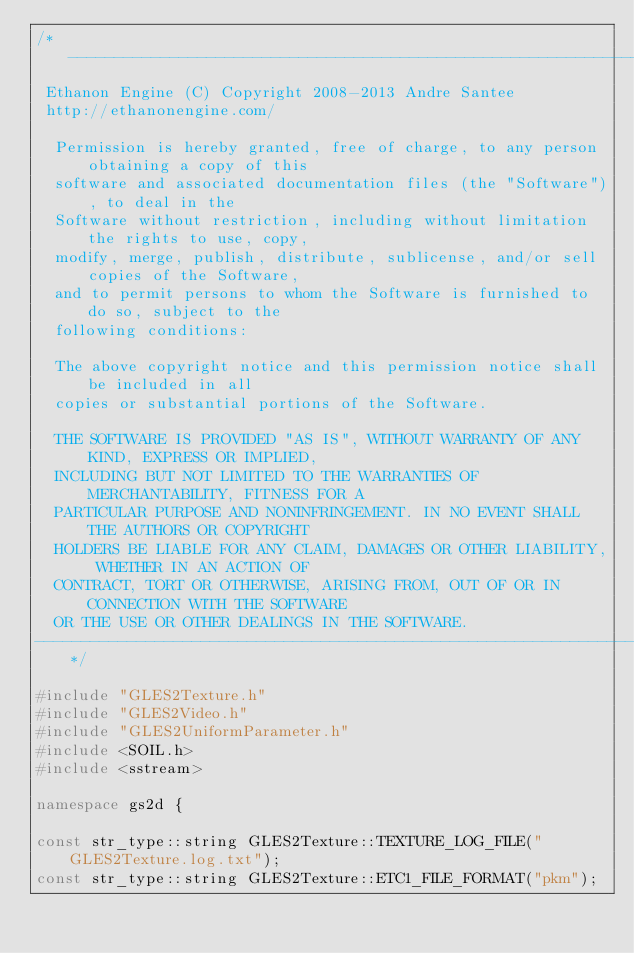<code> <loc_0><loc_0><loc_500><loc_500><_C++_>/*--------------------------------------------------------------------------------------
 Ethanon Engine (C) Copyright 2008-2013 Andre Santee
 http://ethanonengine.com/

	Permission is hereby granted, free of charge, to any person obtaining a copy of this
	software and associated documentation files (the "Software"), to deal in the
	Software without restriction, including without limitation the rights to use, copy,
	modify, merge, publish, distribute, sublicense, and/or sell copies of the Software,
	and to permit persons to whom the Software is furnished to do so, subject to the
	following conditions:

	The above copyright notice and this permission notice shall be included in all
	copies or substantial portions of the Software.

	THE SOFTWARE IS PROVIDED "AS IS", WITHOUT WARRANTY OF ANY KIND, EXPRESS OR IMPLIED,
	INCLUDING BUT NOT LIMITED TO THE WARRANTIES OF MERCHANTABILITY, FITNESS FOR A
	PARTICULAR PURPOSE AND NONINFRINGEMENT. IN NO EVENT SHALL THE AUTHORS OR COPYRIGHT
	HOLDERS BE LIABLE FOR ANY CLAIM, DAMAGES OR OTHER LIABILITY, WHETHER IN AN ACTION OF
	CONTRACT, TORT OR OTHERWISE, ARISING FROM, OUT OF OR IN CONNECTION WITH THE SOFTWARE
	OR THE USE OR OTHER DEALINGS IN THE SOFTWARE.
--------------------------------------------------------------------------------------*/

#include "GLES2Texture.h"
#include "GLES2Video.h"
#include "GLES2UniformParameter.h"
#include <SOIL.h>
#include <sstream>

namespace gs2d {

const str_type::string GLES2Texture::TEXTURE_LOG_FILE("GLES2Texture.log.txt");
const str_type::string GLES2Texture::ETC1_FILE_FORMAT("pkm");</code> 